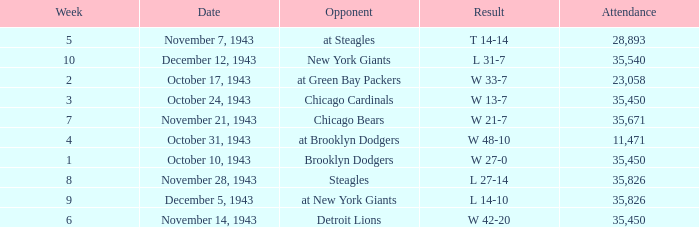How many attendances have 9 as the week? 1.0. 